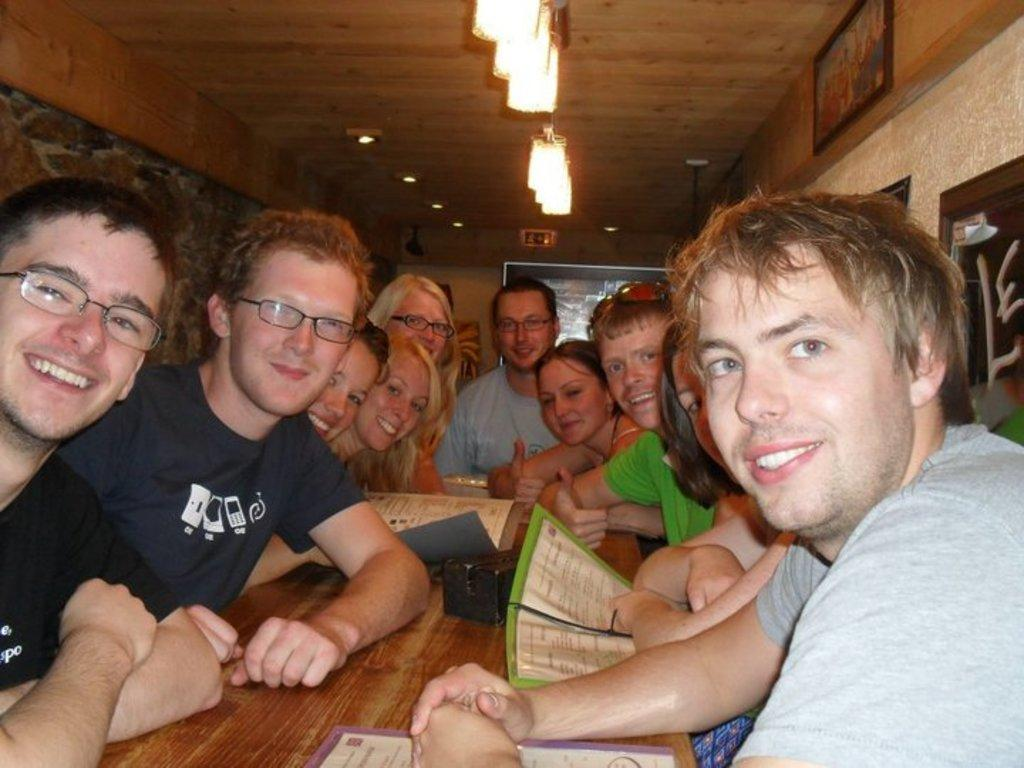What are the people in the image doing? The people in the image are sitting near a table. What can be found on the table in the image? Menu cards are present on the table. What decorative items can be seen on the wall? There are photo frames on the wall. What type of lighting is visible in the image? Ceiling lights are visible in the image. What type of star can be seen performing on the stage in the image? There is no star or stage present in the image; it features people sitting near a table with menu cards and photo frames on the wall. 